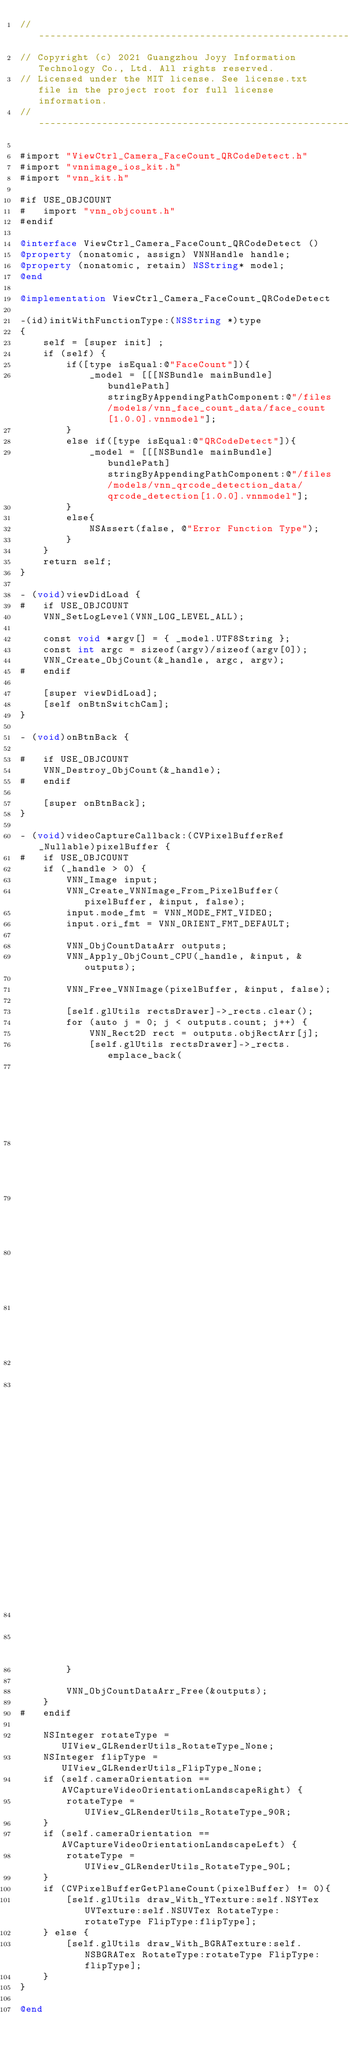<code> <loc_0><loc_0><loc_500><loc_500><_ObjectiveC_>//-------------------------------------------------------------------------------------------------------
// Copyright (c) 2021 Guangzhou Joyy Information Technology Co., Ltd. All rights reserved.
// Licensed under the MIT license. See license.txt file in the project root for full license information.
//-------------------------------------------------------------------------------------------------------

#import "ViewCtrl_Camera_FaceCount_QRCodeDetect.h"
#import "vnnimage_ios_kit.h"
#import "vnn_kit.h"

#if USE_OBJCOUNT
#   import "vnn_objcount.h"
#endif

@interface ViewCtrl_Camera_FaceCount_QRCodeDetect ()
@property (nonatomic, assign) VNNHandle handle;
@property (nonatomic, retain) NSString* model;
@end

@implementation ViewCtrl_Camera_FaceCount_QRCodeDetect

-(id)initWithFunctionType:(NSString *)type
{
    self = [super init] ;
    if (self) {
        if([type isEqual:@"FaceCount"]){
            _model = [[[NSBundle mainBundle] bundlePath] stringByAppendingPathComponent:@"/files/models/vnn_face_count_data/face_count[1.0.0].vnnmodel"];
        }
        else if([type isEqual:@"QRCodeDetect"]){
            _model = [[[NSBundle mainBundle] bundlePath] stringByAppendingPathComponent:@"/files/models/vnn_qrcode_detection_data/qrcode_detection[1.0.0].vnnmodel"];
        }
        else{
            NSAssert(false, @"Error Function Type");
        }
    }
    return self;
}

- (void)viewDidLoad {
#   if USE_OBJCOUNT
    VNN_SetLogLevel(VNN_LOG_LEVEL_ALL);
    
    const void *argv[] = { _model.UTF8String };
    const int argc = sizeof(argv)/sizeof(argv[0]);
    VNN_Create_ObjCount(&_handle, argc, argv);
#   endif
    
    [super viewDidLoad];
    [self onBtnSwitchCam];
}

- (void)onBtnBack {

#   if USE_OBJCOUNT
    VNN_Destroy_ObjCount(&_handle);
#   endif
    
    [super onBtnBack];
}

- (void)videoCaptureCallback:(CVPixelBufferRef _Nullable)pixelBuffer {
#   if USE_OBJCOUNT
    if (_handle > 0) {
        VNN_Image input;
        VNN_Create_VNNImage_From_PixelBuffer(pixelBuffer, &input, false);
        input.mode_fmt = VNN_MODE_FMT_VIDEO;
        input.ori_fmt = VNN_ORIENT_FMT_DEFAULT;
        
        VNN_ObjCountDataArr outputs;
        VNN_Apply_ObjCount_CPU(_handle, &input, &outputs);
        
        VNN_Free_VNNImage(pixelBuffer, &input, false);
        
        [self.glUtils rectsDrawer]->_rects.clear();
        for (auto j = 0; j < outputs.count; j++) {
            VNN_Rect2D rect = outputs.objRectArr[j];
            [self.glUtils rectsDrawer]->_rects.emplace_back(
                                                            vnn::renderkit::DrawRect2D(
                                                                                         rect.x0,
                                                                                         rect.y0,
                                                                                         rect.x1,
                                                                                         rect.y1,
                                                                                         15,
                                                                                       vnn::renderkit::DrawColorRGBA(0.f, 1.f, 0.f, 1.f)
                                                                                         )
                                                            );
        }
        
        VNN_ObjCountDataArr_Free(&outputs);
    }
#   endif
    
    NSInteger rotateType = UIView_GLRenderUtils_RotateType_None;
    NSInteger flipType = UIView_GLRenderUtils_FlipType_None;
    if (self.cameraOrientation == AVCaptureVideoOrientationLandscapeRight) {
        rotateType = UIView_GLRenderUtils_RotateType_90R;
    }
    if (self.cameraOrientation == AVCaptureVideoOrientationLandscapeLeft) {
        rotateType = UIView_GLRenderUtils_RotateType_90L;
    }
    if (CVPixelBufferGetPlaneCount(pixelBuffer) != 0){
        [self.glUtils draw_With_YTexture:self.NSYTex UVTexture:self.NSUVTex RotateType:rotateType FlipType:flipType];
    } else {
        [self.glUtils draw_With_BGRATexture:self.NSBGRATex RotateType:rotateType FlipType:flipType];
    }
}

@end
</code> 